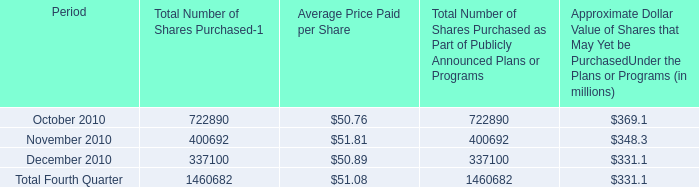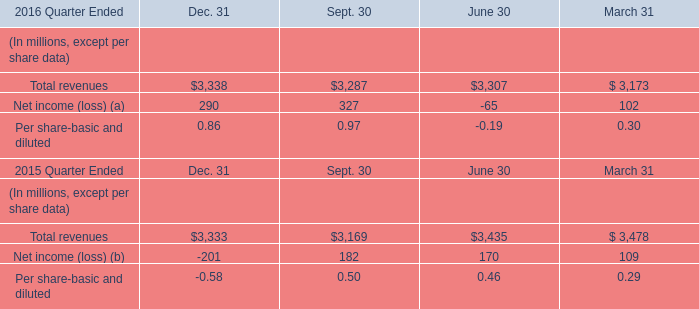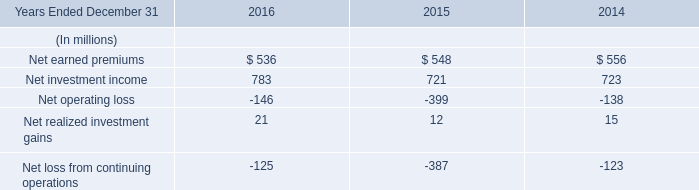What is the sum of Total revenues in 2016? (in million) 
Computations: (((3338 + 3287) + 3307) + 3173)
Answer: 13105.0. 